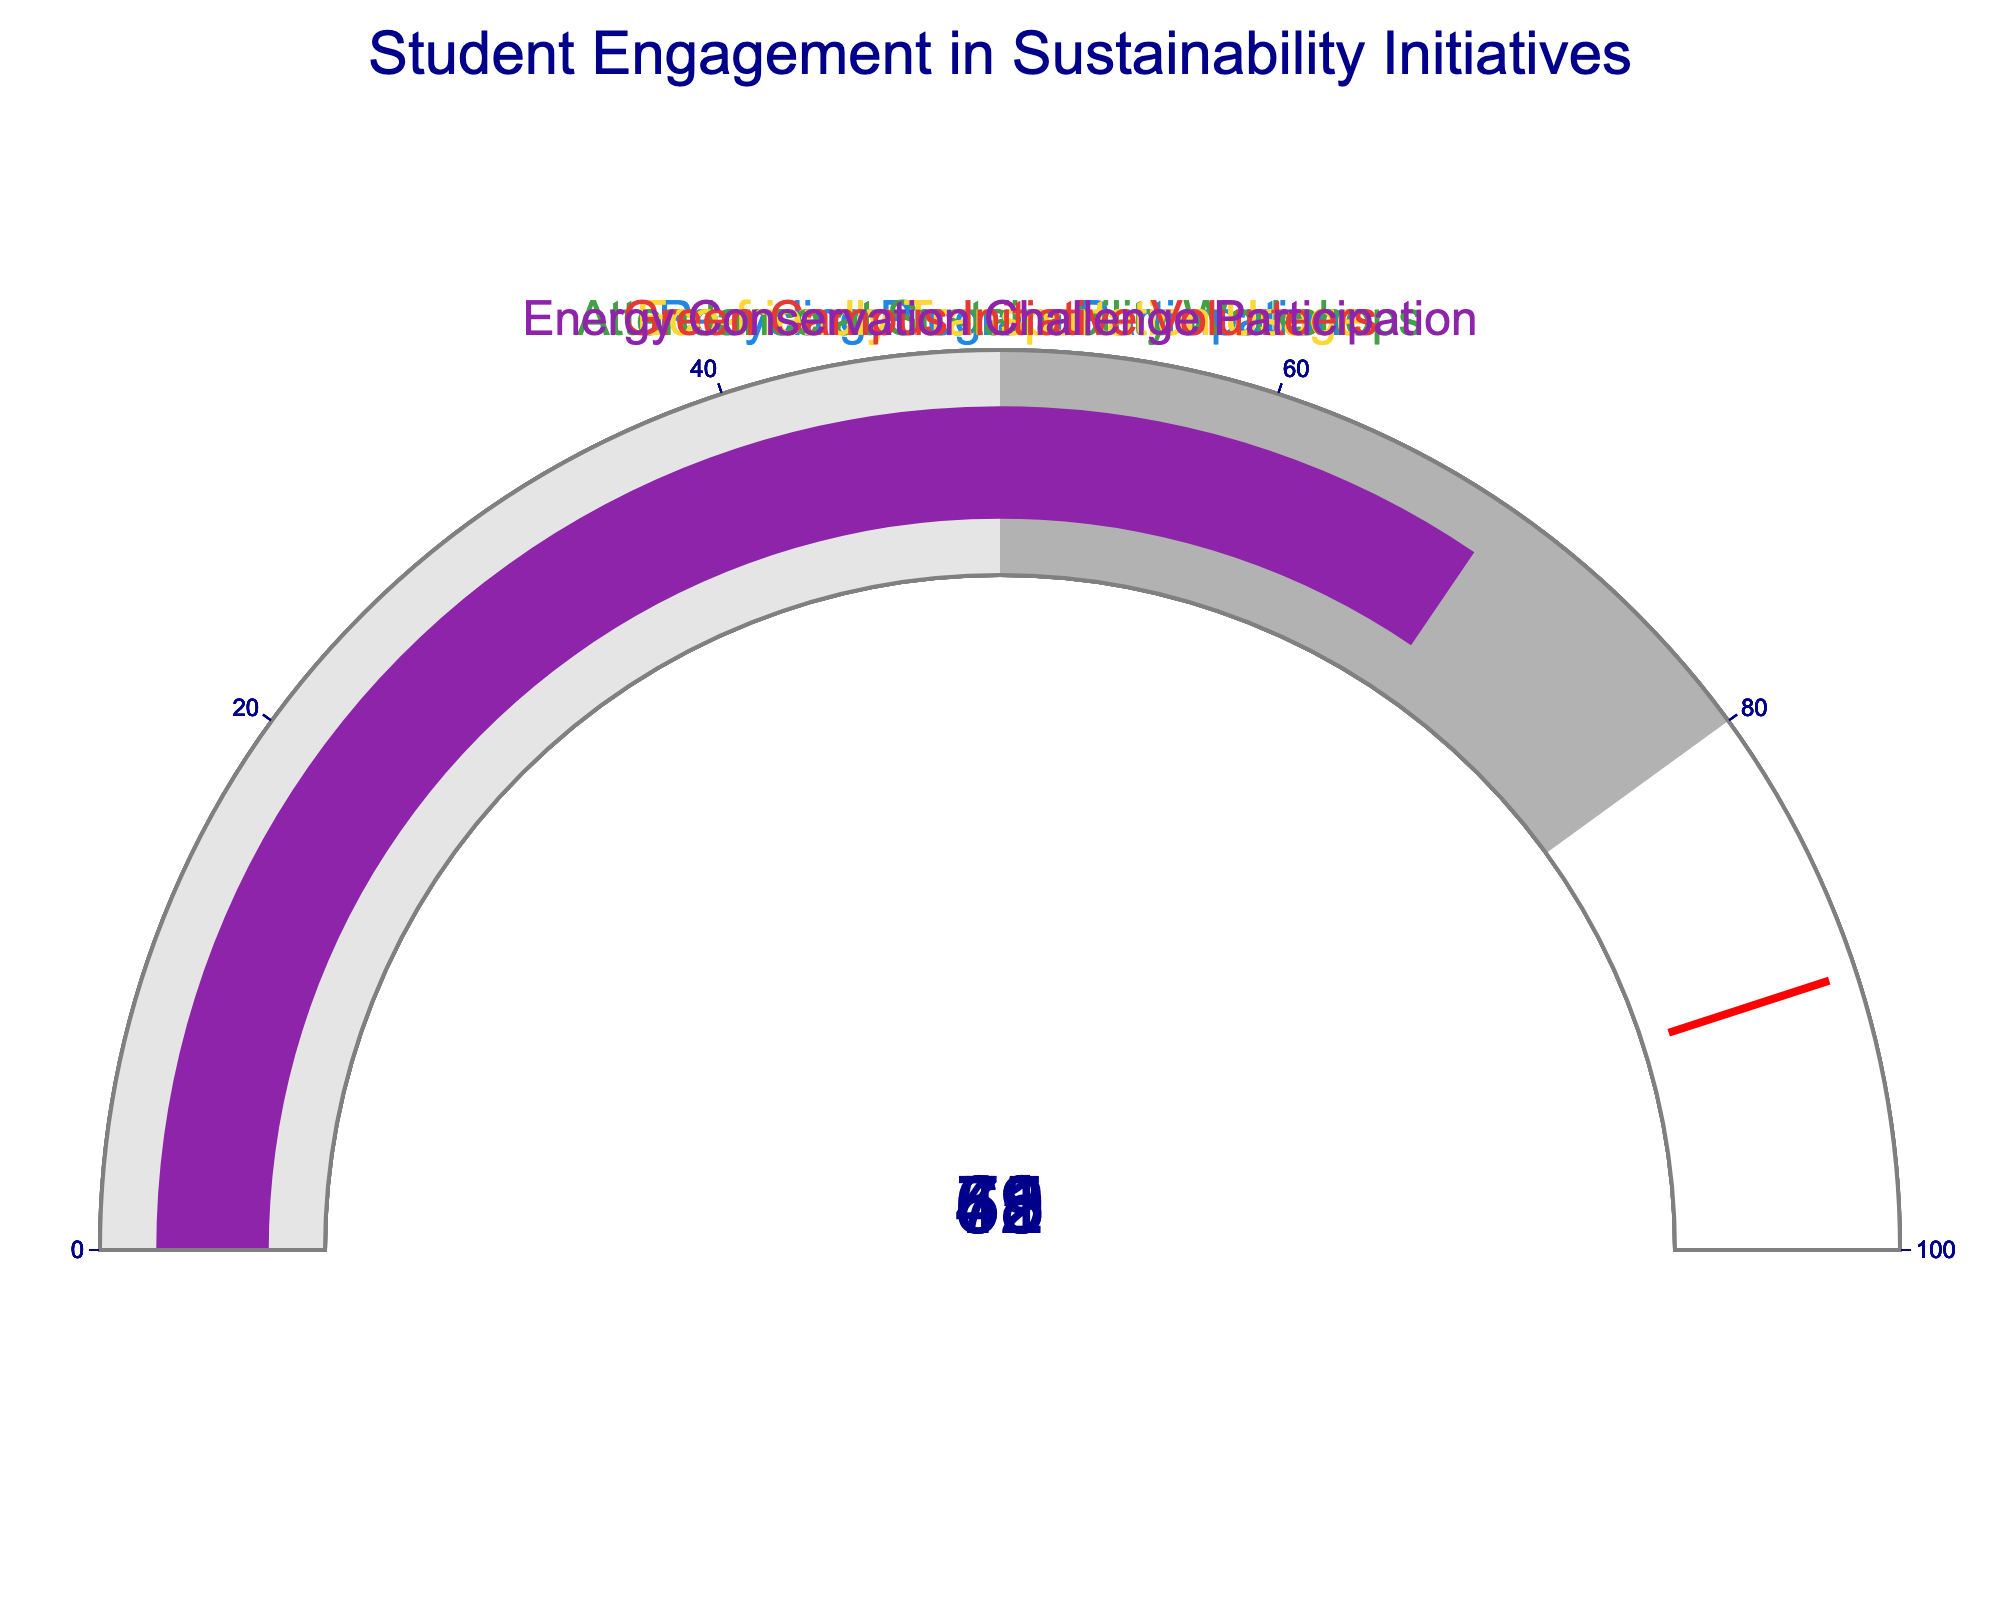What's the title of the figure? The title is usually placed at the top and is designed to give a quick overview of what the figure represents.
Answer: "Student Engagement in Sustainability Initiatives" What percentage of students participate in the Recycling Program? Look for the gauge labeled "Recycling Program Participation" and read the value indicated by the needle.
Answer: 78% Which engagement metric has the lowest participation rate? Examine all gauges and compare their values. Identify the one with the smallest number.
Answer: Green Campus Initiative Volunteers What is the combined participation percentage of the Energy Conservation Challenge and Attendance at Sustainability Workshops? Find the values for "Energy Conservation Challenge Participation" and "Attendance at Sustainability Workshops" and sum them: 69 + 62.
Answer: 131% How much higher is the Recycling Program participation compared to the Green Campus Initiative Volunteers? Subtract the percentage for "Green Campus Initiative Volunteers" from the percentage for "Recycling Program Participation": 78 - 41.
Answer: 37% What is the average percentage of student engagement across all metrics? Sum the percentages of all metrics and divide by the number of metrics: (78 + 62 + 55 + 41 + 69) / 5 = 61.
Answer: 61% Which metric is closest to a 50% participation rate? Compare all the values to 50% and identify which number is closest.
Answer: Eco-friendly Transportation Usage What percentage of students participate in Eco-friendly Transportation Usage? Look for the gauge labeled "Eco-friendly Transportation Usage" and read the value indicated by the needle.
Answer: 55% How does the participation in the Recycling Program compare with Eco-friendly Transportation Usage? Compare the percentages for both metrics: 78% for Recycling Program Participation and 55% for Eco-friendly Transportation Usage.
Answer: Recycling Program Participation is higher 